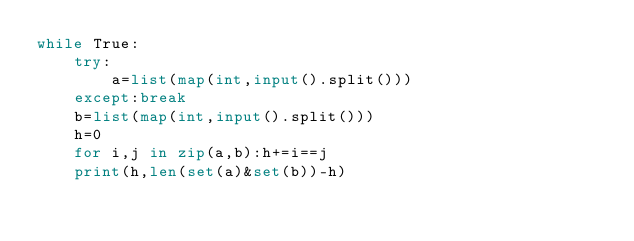<code> <loc_0><loc_0><loc_500><loc_500><_Python_>while True:
    try:
        a=list(map(int,input().split()))
    except:break
    b=list(map(int,input().split()))
    h=0
    for i,j in zip(a,b):h+=i==j
    print(h,len(set(a)&set(b))-h)
</code> 